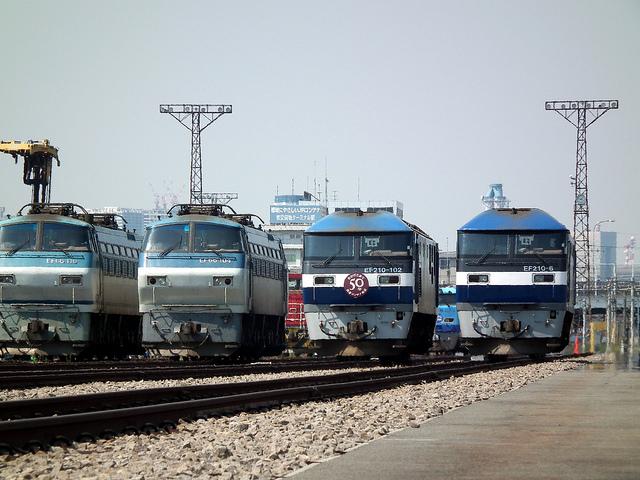How many trains are in the picture?
Write a very short answer. 4. Where is the picture taken of the trains?
Be succinct. Train station. What color are the trains?
Write a very short answer. Blue. Are all the trains the same?
Short answer required. No. 